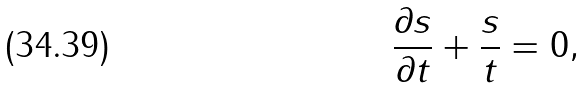<formula> <loc_0><loc_0><loc_500><loc_500>\frac { \partial s } { \partial t } + \frac { s } { t } = 0 ,</formula> 